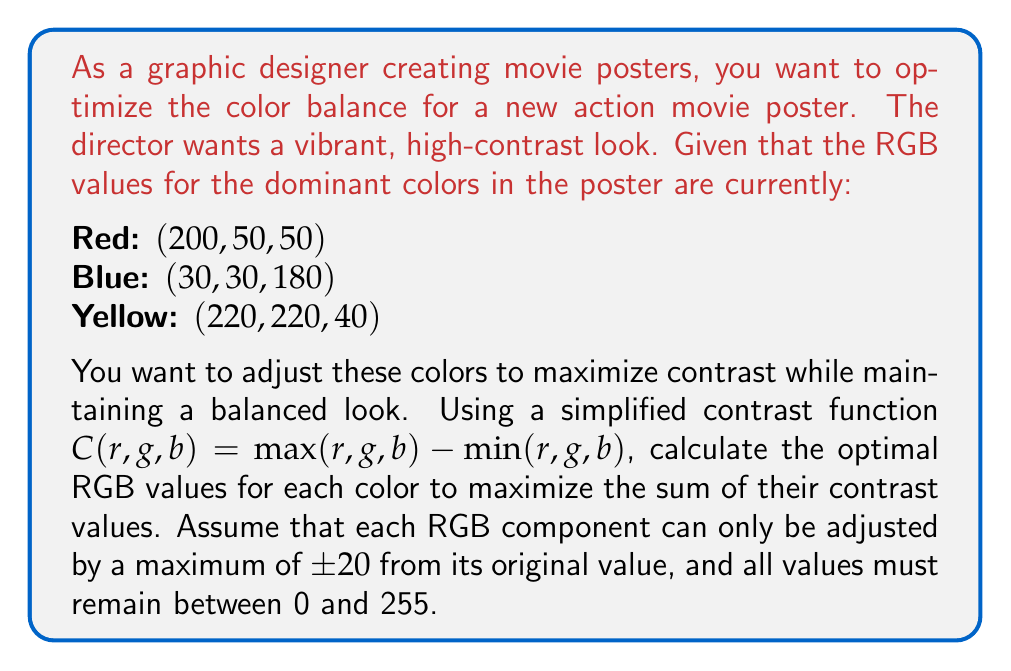Show me your answer to this math problem. To solve this problem, we need to follow these steps:

1) First, let's define our variables. For each color, we'll use $r$, $g$, and $b$ with subscripts to denote the color:

   Red: $(r_r, g_r, b_r)$
   Blue: $(r_b, g_b, b_b)$
   Yellow: $(r_y, g_y, b_y)$

2) Our objective function is to maximize the sum of contrasts:

   $$\max [C(r_r,g_r,b_r) + C(r_b,g_b,b_b) + C(r_y,g_y,b_y)]$$

3) Given the constraints:
   
   - Each component can be adjusted by a maximum of ±20
   - All values must be between 0 and 255

4) Let's consider each color separately:

   For Red $(200, 50, 50)$:
   - $r_r$ can be between 180 and 220
   - $g_r$ and $b_r$ can be between 30 and 70

   For Blue $(30, 30, 180)$:
   - $r_b$ and $g_b$ can be between 10 and 50
   - $b_b$ can be between 160 and 200

   For Yellow $(220, 220, 40)$:
   - $r_y$ and $g_y$ can be between 200 and 240
   - $b_y$ can be between 20 and 60

5) To maximize contrast for each color, we need to maximize the difference between the highest and lowest components:

   For Red: Maximize $r_r$, minimize $g_r$ and $b_r$
   Optimal: $(220, 30, 30)$, Contrast = 190

   For Blue: Maximize $b_b$, minimize $r_b$ and $g_b$
   Optimal: $(10, 10, 200)$, Contrast = 190

   For Yellow: Maximize $r_y$ and $g_y$, minimize $b_y$
   Optimal: $(240, 240, 20)$, Contrast = 220

6) The sum of contrasts is now maximized at $190 + 190 + 220 = 600$
Answer: The optimal RGB values for maximum contrast are:

Red: $(220, 30, 30)$
Blue: $(10, 10, 200)$
Yellow: $(240, 240, 20)$

The maximum sum of contrasts is 600. 